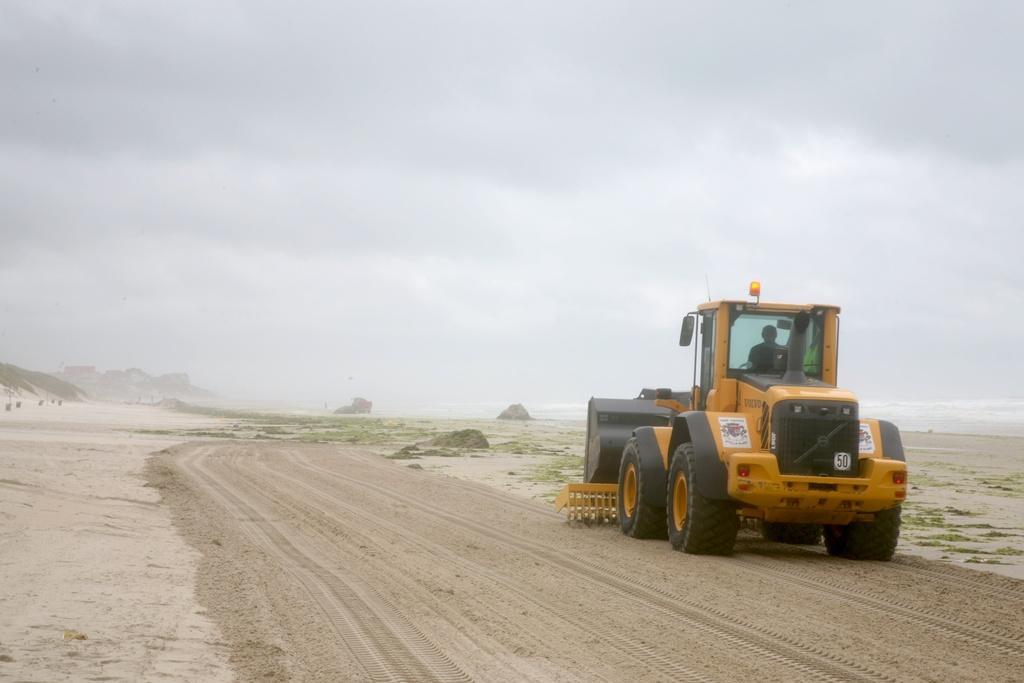What is the main feature of the image? There is a road in the image. What is happening on the road? A rolling vehicle is present on the road. Can you describe the person in the image? There is a person in the image. What type of terrain is visible in the image? Sand, mountains, and grass are present in the image. What can be seen in the background of the image? The sky is visible in the background of the image. What type of poison is being used to fuel the vehicle in the image? There is no mention of poison or fuel in the image; it simply shows a road, a rolling vehicle, and a person. 